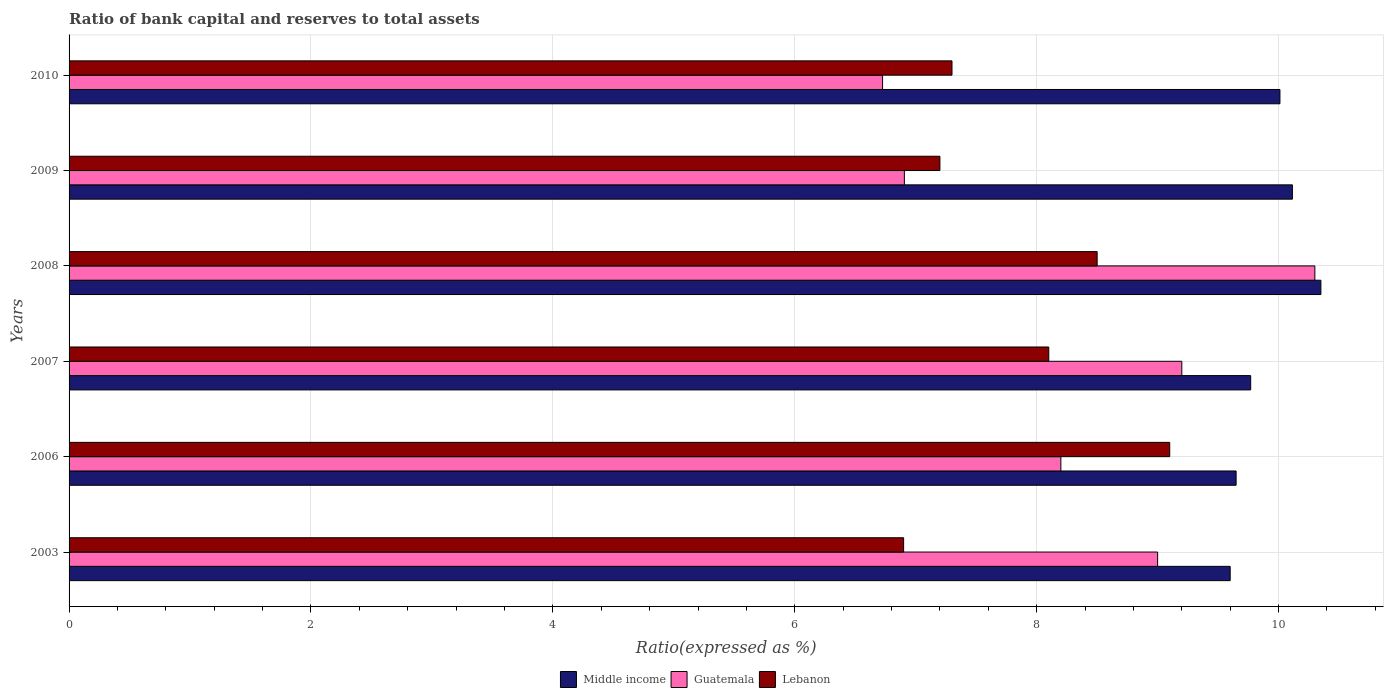How many different coloured bars are there?
Your response must be concise. 3. How many groups of bars are there?
Make the answer very short. 6. Are the number of bars per tick equal to the number of legend labels?
Offer a terse response. Yes. Are the number of bars on each tick of the Y-axis equal?
Keep it short and to the point. Yes. How many bars are there on the 3rd tick from the top?
Ensure brevity in your answer.  3. How many bars are there on the 5th tick from the bottom?
Make the answer very short. 3. Across all years, what is the maximum ratio of bank capital and reserves to total assets in Guatemala?
Provide a succinct answer. 10.3. In which year was the ratio of bank capital and reserves to total assets in Guatemala maximum?
Provide a short and direct response. 2008. What is the total ratio of bank capital and reserves to total assets in Lebanon in the graph?
Offer a terse response. 47.1. What is the difference between the ratio of bank capital and reserves to total assets in Middle income in 2003 and that in 2007?
Your response must be concise. -0.17. What is the average ratio of bank capital and reserves to total assets in Lebanon per year?
Offer a very short reply. 7.85. In the year 2009, what is the difference between the ratio of bank capital and reserves to total assets in Guatemala and ratio of bank capital and reserves to total assets in Lebanon?
Give a very brief answer. -0.29. In how many years, is the ratio of bank capital and reserves to total assets in Guatemala greater than 7.6 %?
Offer a very short reply. 4. What is the ratio of the ratio of bank capital and reserves to total assets in Middle income in 2003 to that in 2007?
Your answer should be very brief. 0.98. Is the difference between the ratio of bank capital and reserves to total assets in Guatemala in 2007 and 2008 greater than the difference between the ratio of bank capital and reserves to total assets in Lebanon in 2007 and 2008?
Your response must be concise. No. What is the difference between the highest and the second highest ratio of bank capital and reserves to total assets in Lebanon?
Your response must be concise. 0.6. What is the difference between the highest and the lowest ratio of bank capital and reserves to total assets in Lebanon?
Offer a terse response. 2.2. In how many years, is the ratio of bank capital and reserves to total assets in Lebanon greater than the average ratio of bank capital and reserves to total assets in Lebanon taken over all years?
Give a very brief answer. 3. Is the sum of the ratio of bank capital and reserves to total assets in Guatemala in 2007 and 2009 greater than the maximum ratio of bank capital and reserves to total assets in Middle income across all years?
Your response must be concise. Yes. What does the 1st bar from the top in 2009 represents?
Your answer should be compact. Lebanon. Is it the case that in every year, the sum of the ratio of bank capital and reserves to total assets in Guatemala and ratio of bank capital and reserves to total assets in Lebanon is greater than the ratio of bank capital and reserves to total assets in Middle income?
Ensure brevity in your answer.  Yes. How many bars are there?
Give a very brief answer. 18. How many legend labels are there?
Give a very brief answer. 3. How are the legend labels stacked?
Offer a very short reply. Horizontal. What is the title of the graph?
Make the answer very short. Ratio of bank capital and reserves to total assets. Does "Puerto Rico" appear as one of the legend labels in the graph?
Keep it short and to the point. No. What is the label or title of the X-axis?
Your response must be concise. Ratio(expressed as %). What is the Ratio(expressed as %) in Guatemala in 2003?
Give a very brief answer. 9. What is the Ratio(expressed as %) of Lebanon in 2003?
Your answer should be compact. 6.9. What is the Ratio(expressed as %) in Middle income in 2006?
Offer a very short reply. 9.65. What is the Ratio(expressed as %) in Guatemala in 2006?
Your response must be concise. 8.2. What is the Ratio(expressed as %) in Middle income in 2007?
Give a very brief answer. 9.77. What is the Ratio(expressed as %) of Middle income in 2008?
Provide a short and direct response. 10.35. What is the Ratio(expressed as %) in Guatemala in 2008?
Make the answer very short. 10.3. What is the Ratio(expressed as %) in Lebanon in 2008?
Give a very brief answer. 8.5. What is the Ratio(expressed as %) of Middle income in 2009?
Your answer should be compact. 10.11. What is the Ratio(expressed as %) of Guatemala in 2009?
Offer a very short reply. 6.91. What is the Ratio(expressed as %) of Middle income in 2010?
Ensure brevity in your answer.  10.01. What is the Ratio(expressed as %) of Guatemala in 2010?
Your answer should be compact. 6.73. Across all years, what is the maximum Ratio(expressed as %) in Middle income?
Your response must be concise. 10.35. Across all years, what is the maximum Ratio(expressed as %) of Guatemala?
Provide a succinct answer. 10.3. Across all years, what is the minimum Ratio(expressed as %) of Guatemala?
Ensure brevity in your answer.  6.73. What is the total Ratio(expressed as %) in Middle income in the graph?
Your answer should be very brief. 59.49. What is the total Ratio(expressed as %) of Guatemala in the graph?
Provide a short and direct response. 50.33. What is the total Ratio(expressed as %) of Lebanon in the graph?
Give a very brief answer. 47.1. What is the difference between the Ratio(expressed as %) in Middle income in 2003 and that in 2006?
Provide a short and direct response. -0.05. What is the difference between the Ratio(expressed as %) in Lebanon in 2003 and that in 2006?
Offer a terse response. -2.2. What is the difference between the Ratio(expressed as %) in Middle income in 2003 and that in 2007?
Offer a terse response. -0.17. What is the difference between the Ratio(expressed as %) in Lebanon in 2003 and that in 2007?
Provide a succinct answer. -1.2. What is the difference between the Ratio(expressed as %) of Middle income in 2003 and that in 2008?
Offer a terse response. -0.75. What is the difference between the Ratio(expressed as %) of Guatemala in 2003 and that in 2008?
Your answer should be very brief. -1.3. What is the difference between the Ratio(expressed as %) of Lebanon in 2003 and that in 2008?
Your answer should be very brief. -1.6. What is the difference between the Ratio(expressed as %) of Middle income in 2003 and that in 2009?
Ensure brevity in your answer.  -0.51. What is the difference between the Ratio(expressed as %) of Guatemala in 2003 and that in 2009?
Give a very brief answer. 2.09. What is the difference between the Ratio(expressed as %) of Middle income in 2003 and that in 2010?
Your answer should be very brief. -0.41. What is the difference between the Ratio(expressed as %) in Guatemala in 2003 and that in 2010?
Ensure brevity in your answer.  2.27. What is the difference between the Ratio(expressed as %) in Lebanon in 2003 and that in 2010?
Give a very brief answer. -0.4. What is the difference between the Ratio(expressed as %) in Middle income in 2006 and that in 2007?
Your response must be concise. -0.12. What is the difference between the Ratio(expressed as %) in Middle income in 2006 and that in 2008?
Your answer should be very brief. -0.7. What is the difference between the Ratio(expressed as %) of Lebanon in 2006 and that in 2008?
Your answer should be compact. 0.6. What is the difference between the Ratio(expressed as %) in Middle income in 2006 and that in 2009?
Give a very brief answer. -0.47. What is the difference between the Ratio(expressed as %) in Guatemala in 2006 and that in 2009?
Offer a very short reply. 1.29. What is the difference between the Ratio(expressed as %) in Lebanon in 2006 and that in 2009?
Your answer should be compact. 1.9. What is the difference between the Ratio(expressed as %) of Middle income in 2006 and that in 2010?
Give a very brief answer. -0.36. What is the difference between the Ratio(expressed as %) in Guatemala in 2006 and that in 2010?
Offer a terse response. 1.47. What is the difference between the Ratio(expressed as %) in Middle income in 2007 and that in 2008?
Your answer should be very brief. -0.58. What is the difference between the Ratio(expressed as %) in Guatemala in 2007 and that in 2008?
Your response must be concise. -1.1. What is the difference between the Ratio(expressed as %) in Lebanon in 2007 and that in 2008?
Make the answer very short. -0.4. What is the difference between the Ratio(expressed as %) of Middle income in 2007 and that in 2009?
Ensure brevity in your answer.  -0.34. What is the difference between the Ratio(expressed as %) in Guatemala in 2007 and that in 2009?
Make the answer very short. 2.29. What is the difference between the Ratio(expressed as %) in Lebanon in 2007 and that in 2009?
Your answer should be very brief. 0.9. What is the difference between the Ratio(expressed as %) in Middle income in 2007 and that in 2010?
Your answer should be compact. -0.24. What is the difference between the Ratio(expressed as %) in Guatemala in 2007 and that in 2010?
Keep it short and to the point. 2.47. What is the difference between the Ratio(expressed as %) in Middle income in 2008 and that in 2009?
Provide a short and direct response. 0.24. What is the difference between the Ratio(expressed as %) of Guatemala in 2008 and that in 2009?
Provide a short and direct response. 3.39. What is the difference between the Ratio(expressed as %) of Lebanon in 2008 and that in 2009?
Give a very brief answer. 1.3. What is the difference between the Ratio(expressed as %) of Middle income in 2008 and that in 2010?
Provide a succinct answer. 0.34. What is the difference between the Ratio(expressed as %) of Guatemala in 2008 and that in 2010?
Keep it short and to the point. 3.57. What is the difference between the Ratio(expressed as %) of Lebanon in 2008 and that in 2010?
Provide a succinct answer. 1.2. What is the difference between the Ratio(expressed as %) of Middle income in 2009 and that in 2010?
Your answer should be compact. 0.1. What is the difference between the Ratio(expressed as %) in Guatemala in 2009 and that in 2010?
Provide a short and direct response. 0.18. What is the difference between the Ratio(expressed as %) in Lebanon in 2009 and that in 2010?
Provide a succinct answer. -0.1. What is the difference between the Ratio(expressed as %) in Middle income in 2003 and the Ratio(expressed as %) in Lebanon in 2006?
Offer a terse response. 0.5. What is the difference between the Ratio(expressed as %) of Middle income in 2003 and the Ratio(expressed as %) of Guatemala in 2007?
Your answer should be compact. 0.4. What is the difference between the Ratio(expressed as %) of Middle income in 2003 and the Ratio(expressed as %) of Guatemala in 2009?
Provide a succinct answer. 2.69. What is the difference between the Ratio(expressed as %) in Middle income in 2003 and the Ratio(expressed as %) in Lebanon in 2009?
Give a very brief answer. 2.4. What is the difference between the Ratio(expressed as %) of Guatemala in 2003 and the Ratio(expressed as %) of Lebanon in 2009?
Provide a short and direct response. 1.8. What is the difference between the Ratio(expressed as %) in Middle income in 2003 and the Ratio(expressed as %) in Guatemala in 2010?
Provide a short and direct response. 2.87. What is the difference between the Ratio(expressed as %) in Middle income in 2003 and the Ratio(expressed as %) in Lebanon in 2010?
Ensure brevity in your answer.  2.3. What is the difference between the Ratio(expressed as %) in Guatemala in 2003 and the Ratio(expressed as %) in Lebanon in 2010?
Offer a terse response. 1.7. What is the difference between the Ratio(expressed as %) in Middle income in 2006 and the Ratio(expressed as %) in Guatemala in 2007?
Offer a very short reply. 0.45. What is the difference between the Ratio(expressed as %) of Middle income in 2006 and the Ratio(expressed as %) of Lebanon in 2007?
Provide a succinct answer. 1.55. What is the difference between the Ratio(expressed as %) of Middle income in 2006 and the Ratio(expressed as %) of Guatemala in 2008?
Your answer should be very brief. -0.65. What is the difference between the Ratio(expressed as %) in Middle income in 2006 and the Ratio(expressed as %) in Lebanon in 2008?
Offer a very short reply. 1.15. What is the difference between the Ratio(expressed as %) in Middle income in 2006 and the Ratio(expressed as %) in Guatemala in 2009?
Keep it short and to the point. 2.74. What is the difference between the Ratio(expressed as %) in Middle income in 2006 and the Ratio(expressed as %) in Lebanon in 2009?
Your answer should be very brief. 2.45. What is the difference between the Ratio(expressed as %) in Guatemala in 2006 and the Ratio(expressed as %) in Lebanon in 2009?
Make the answer very short. 1. What is the difference between the Ratio(expressed as %) in Middle income in 2006 and the Ratio(expressed as %) in Guatemala in 2010?
Your answer should be compact. 2.92. What is the difference between the Ratio(expressed as %) of Middle income in 2006 and the Ratio(expressed as %) of Lebanon in 2010?
Your response must be concise. 2.35. What is the difference between the Ratio(expressed as %) of Middle income in 2007 and the Ratio(expressed as %) of Guatemala in 2008?
Provide a short and direct response. -0.53. What is the difference between the Ratio(expressed as %) of Middle income in 2007 and the Ratio(expressed as %) of Lebanon in 2008?
Ensure brevity in your answer.  1.27. What is the difference between the Ratio(expressed as %) in Middle income in 2007 and the Ratio(expressed as %) in Guatemala in 2009?
Offer a terse response. 2.86. What is the difference between the Ratio(expressed as %) of Middle income in 2007 and the Ratio(expressed as %) of Lebanon in 2009?
Keep it short and to the point. 2.57. What is the difference between the Ratio(expressed as %) of Guatemala in 2007 and the Ratio(expressed as %) of Lebanon in 2009?
Offer a terse response. 2. What is the difference between the Ratio(expressed as %) of Middle income in 2007 and the Ratio(expressed as %) of Guatemala in 2010?
Offer a very short reply. 3.04. What is the difference between the Ratio(expressed as %) in Middle income in 2007 and the Ratio(expressed as %) in Lebanon in 2010?
Provide a succinct answer. 2.47. What is the difference between the Ratio(expressed as %) of Guatemala in 2007 and the Ratio(expressed as %) of Lebanon in 2010?
Your answer should be very brief. 1.9. What is the difference between the Ratio(expressed as %) in Middle income in 2008 and the Ratio(expressed as %) in Guatemala in 2009?
Offer a terse response. 3.44. What is the difference between the Ratio(expressed as %) of Middle income in 2008 and the Ratio(expressed as %) of Lebanon in 2009?
Ensure brevity in your answer.  3.15. What is the difference between the Ratio(expressed as %) of Middle income in 2008 and the Ratio(expressed as %) of Guatemala in 2010?
Your response must be concise. 3.62. What is the difference between the Ratio(expressed as %) in Middle income in 2008 and the Ratio(expressed as %) in Lebanon in 2010?
Your answer should be very brief. 3.05. What is the difference between the Ratio(expressed as %) in Guatemala in 2008 and the Ratio(expressed as %) in Lebanon in 2010?
Keep it short and to the point. 3. What is the difference between the Ratio(expressed as %) in Middle income in 2009 and the Ratio(expressed as %) in Guatemala in 2010?
Your response must be concise. 3.39. What is the difference between the Ratio(expressed as %) of Middle income in 2009 and the Ratio(expressed as %) of Lebanon in 2010?
Your answer should be compact. 2.81. What is the difference between the Ratio(expressed as %) of Guatemala in 2009 and the Ratio(expressed as %) of Lebanon in 2010?
Your response must be concise. -0.39. What is the average Ratio(expressed as %) in Middle income per year?
Provide a short and direct response. 9.92. What is the average Ratio(expressed as %) in Guatemala per year?
Your answer should be very brief. 8.39. What is the average Ratio(expressed as %) of Lebanon per year?
Offer a terse response. 7.85. In the year 2003, what is the difference between the Ratio(expressed as %) in Middle income and Ratio(expressed as %) in Guatemala?
Your answer should be compact. 0.6. In the year 2003, what is the difference between the Ratio(expressed as %) of Guatemala and Ratio(expressed as %) of Lebanon?
Make the answer very short. 2.1. In the year 2006, what is the difference between the Ratio(expressed as %) in Middle income and Ratio(expressed as %) in Guatemala?
Your answer should be very brief. 1.45. In the year 2006, what is the difference between the Ratio(expressed as %) of Middle income and Ratio(expressed as %) of Lebanon?
Give a very brief answer. 0.55. In the year 2006, what is the difference between the Ratio(expressed as %) of Guatemala and Ratio(expressed as %) of Lebanon?
Provide a short and direct response. -0.9. In the year 2007, what is the difference between the Ratio(expressed as %) of Middle income and Ratio(expressed as %) of Guatemala?
Provide a succinct answer. 0.57. In the year 2007, what is the difference between the Ratio(expressed as %) of Middle income and Ratio(expressed as %) of Lebanon?
Your answer should be compact. 1.67. In the year 2008, what is the difference between the Ratio(expressed as %) in Middle income and Ratio(expressed as %) in Lebanon?
Ensure brevity in your answer.  1.85. In the year 2008, what is the difference between the Ratio(expressed as %) of Guatemala and Ratio(expressed as %) of Lebanon?
Your response must be concise. 1.8. In the year 2009, what is the difference between the Ratio(expressed as %) in Middle income and Ratio(expressed as %) in Guatemala?
Give a very brief answer. 3.21. In the year 2009, what is the difference between the Ratio(expressed as %) in Middle income and Ratio(expressed as %) in Lebanon?
Your answer should be compact. 2.91. In the year 2009, what is the difference between the Ratio(expressed as %) of Guatemala and Ratio(expressed as %) of Lebanon?
Ensure brevity in your answer.  -0.29. In the year 2010, what is the difference between the Ratio(expressed as %) in Middle income and Ratio(expressed as %) in Guatemala?
Give a very brief answer. 3.29. In the year 2010, what is the difference between the Ratio(expressed as %) in Middle income and Ratio(expressed as %) in Lebanon?
Your answer should be compact. 2.71. In the year 2010, what is the difference between the Ratio(expressed as %) of Guatemala and Ratio(expressed as %) of Lebanon?
Your answer should be very brief. -0.57. What is the ratio of the Ratio(expressed as %) in Guatemala in 2003 to that in 2006?
Your answer should be very brief. 1.1. What is the ratio of the Ratio(expressed as %) in Lebanon in 2003 to that in 2006?
Offer a terse response. 0.76. What is the ratio of the Ratio(expressed as %) of Middle income in 2003 to that in 2007?
Ensure brevity in your answer.  0.98. What is the ratio of the Ratio(expressed as %) in Guatemala in 2003 to that in 2007?
Ensure brevity in your answer.  0.98. What is the ratio of the Ratio(expressed as %) in Lebanon in 2003 to that in 2007?
Offer a terse response. 0.85. What is the ratio of the Ratio(expressed as %) in Middle income in 2003 to that in 2008?
Provide a short and direct response. 0.93. What is the ratio of the Ratio(expressed as %) of Guatemala in 2003 to that in 2008?
Give a very brief answer. 0.87. What is the ratio of the Ratio(expressed as %) of Lebanon in 2003 to that in 2008?
Make the answer very short. 0.81. What is the ratio of the Ratio(expressed as %) of Middle income in 2003 to that in 2009?
Make the answer very short. 0.95. What is the ratio of the Ratio(expressed as %) of Guatemala in 2003 to that in 2009?
Your answer should be compact. 1.3. What is the ratio of the Ratio(expressed as %) in Lebanon in 2003 to that in 2009?
Make the answer very short. 0.96. What is the ratio of the Ratio(expressed as %) of Middle income in 2003 to that in 2010?
Your answer should be compact. 0.96. What is the ratio of the Ratio(expressed as %) of Guatemala in 2003 to that in 2010?
Make the answer very short. 1.34. What is the ratio of the Ratio(expressed as %) in Lebanon in 2003 to that in 2010?
Keep it short and to the point. 0.95. What is the ratio of the Ratio(expressed as %) of Guatemala in 2006 to that in 2007?
Offer a very short reply. 0.89. What is the ratio of the Ratio(expressed as %) of Lebanon in 2006 to that in 2007?
Your answer should be very brief. 1.12. What is the ratio of the Ratio(expressed as %) in Middle income in 2006 to that in 2008?
Ensure brevity in your answer.  0.93. What is the ratio of the Ratio(expressed as %) in Guatemala in 2006 to that in 2008?
Offer a terse response. 0.8. What is the ratio of the Ratio(expressed as %) of Lebanon in 2006 to that in 2008?
Your answer should be very brief. 1.07. What is the ratio of the Ratio(expressed as %) in Middle income in 2006 to that in 2009?
Your answer should be compact. 0.95. What is the ratio of the Ratio(expressed as %) of Guatemala in 2006 to that in 2009?
Ensure brevity in your answer.  1.19. What is the ratio of the Ratio(expressed as %) in Lebanon in 2006 to that in 2009?
Your answer should be compact. 1.26. What is the ratio of the Ratio(expressed as %) in Middle income in 2006 to that in 2010?
Provide a short and direct response. 0.96. What is the ratio of the Ratio(expressed as %) of Guatemala in 2006 to that in 2010?
Provide a short and direct response. 1.22. What is the ratio of the Ratio(expressed as %) of Lebanon in 2006 to that in 2010?
Offer a terse response. 1.25. What is the ratio of the Ratio(expressed as %) of Middle income in 2007 to that in 2008?
Give a very brief answer. 0.94. What is the ratio of the Ratio(expressed as %) of Guatemala in 2007 to that in 2008?
Offer a terse response. 0.89. What is the ratio of the Ratio(expressed as %) in Lebanon in 2007 to that in 2008?
Your response must be concise. 0.95. What is the ratio of the Ratio(expressed as %) in Middle income in 2007 to that in 2009?
Give a very brief answer. 0.97. What is the ratio of the Ratio(expressed as %) of Guatemala in 2007 to that in 2009?
Your answer should be compact. 1.33. What is the ratio of the Ratio(expressed as %) in Middle income in 2007 to that in 2010?
Ensure brevity in your answer.  0.98. What is the ratio of the Ratio(expressed as %) of Guatemala in 2007 to that in 2010?
Keep it short and to the point. 1.37. What is the ratio of the Ratio(expressed as %) in Lebanon in 2007 to that in 2010?
Your answer should be compact. 1.11. What is the ratio of the Ratio(expressed as %) in Middle income in 2008 to that in 2009?
Ensure brevity in your answer.  1.02. What is the ratio of the Ratio(expressed as %) of Guatemala in 2008 to that in 2009?
Make the answer very short. 1.49. What is the ratio of the Ratio(expressed as %) in Lebanon in 2008 to that in 2009?
Make the answer very short. 1.18. What is the ratio of the Ratio(expressed as %) in Middle income in 2008 to that in 2010?
Offer a terse response. 1.03. What is the ratio of the Ratio(expressed as %) in Guatemala in 2008 to that in 2010?
Give a very brief answer. 1.53. What is the ratio of the Ratio(expressed as %) in Lebanon in 2008 to that in 2010?
Your response must be concise. 1.16. What is the ratio of the Ratio(expressed as %) in Middle income in 2009 to that in 2010?
Offer a terse response. 1.01. What is the ratio of the Ratio(expressed as %) of Guatemala in 2009 to that in 2010?
Ensure brevity in your answer.  1.03. What is the ratio of the Ratio(expressed as %) of Lebanon in 2009 to that in 2010?
Your response must be concise. 0.99. What is the difference between the highest and the second highest Ratio(expressed as %) in Middle income?
Offer a terse response. 0.24. What is the difference between the highest and the second highest Ratio(expressed as %) in Guatemala?
Provide a succinct answer. 1.1. What is the difference between the highest and the second highest Ratio(expressed as %) in Lebanon?
Provide a short and direct response. 0.6. What is the difference between the highest and the lowest Ratio(expressed as %) of Middle income?
Offer a very short reply. 0.75. What is the difference between the highest and the lowest Ratio(expressed as %) in Guatemala?
Keep it short and to the point. 3.57. 